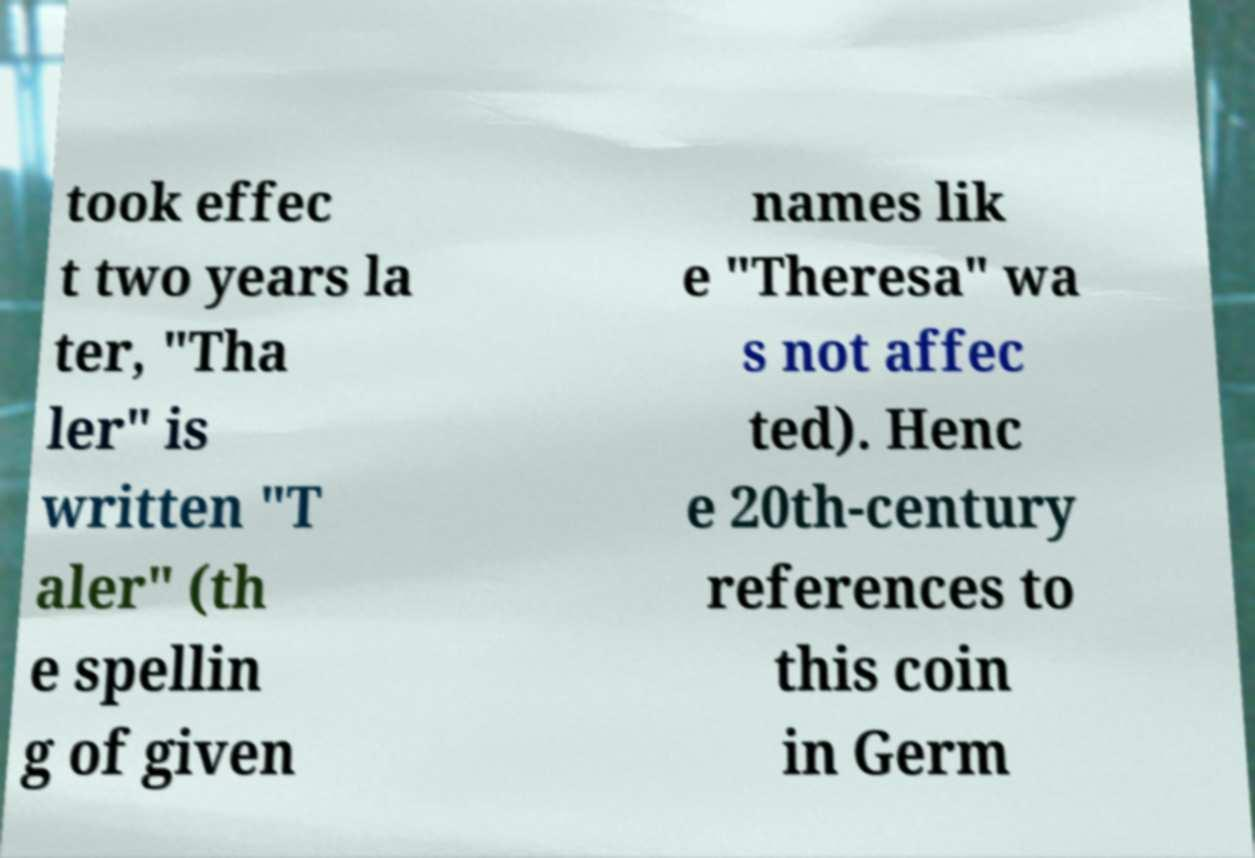There's text embedded in this image that I need extracted. Can you transcribe it verbatim? took effec t two years la ter, "Tha ler" is written "T aler" (th e spellin g of given names lik e "Theresa" wa s not affec ted). Henc e 20th-century references to this coin in Germ 